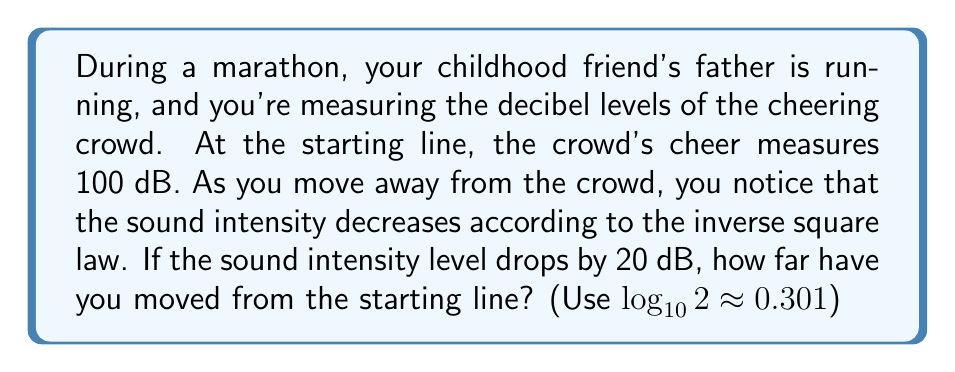Help me with this question. Let's approach this step-by-step:

1) The inverse square law states that the intensity of sound is inversely proportional to the square of the distance from the source. We can express this as:

   $$I_2 = I_1 \cdot \left(\frac{r_1}{r_2}\right)^2$$

   where $I_1$ and $I_2$ are the intensities at distances $r_1$ and $r_2$ respectively.

2) The relationship between sound intensity level (L) in dB and intensity (I) is given by:

   $$L = 10 \log_{10}\left(\frac{I}{I_0}\right)$$

   where $I_0$ is the reference intensity.

3) The change in sound level is 20 dB. We can write:

   $$20 = 10 \log_{10}\left(\frac{I_1}{I_2}\right)$$

4) Simplifying:

   $$2 = \log_{10}\left(\frac{I_1}{I_2}\right)$$

5) Taking $10$ to the power of both sides:

   $$10^2 = \frac{I_1}{I_2}$$

6) This means:

   $$100 = \frac{I_1}{I_2} = \left(\frac{r_2}{r_1}\right)^2$$

7) Taking the square root of both sides:

   $$10 = \frac{r_2}{r_1}$$

8) If we set $r_1 = 1$ (unit distance at the starting line), then:

   $$r_2 = 10r_1 = 10$$

Therefore, you have moved 10 times the initial distance from the starting line.
Answer: 10 times the initial distance 